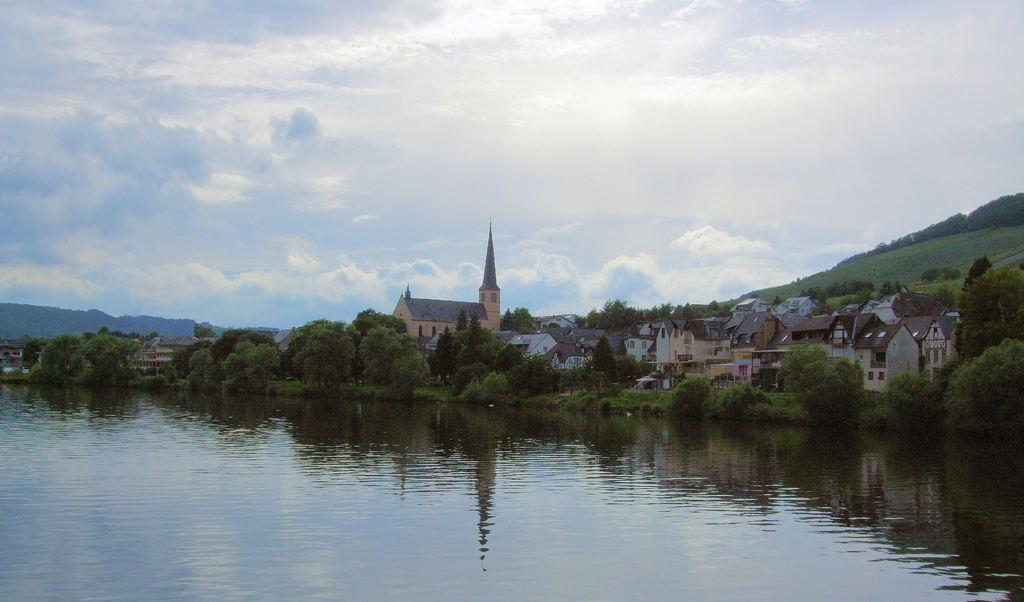What is located in the center of the image? There are trees, buildings, and plants in the center of the image. What can be seen at the bottom of the image? There is a river at the bottom of the image. What is visible in the background of the image? There are mountains in the background of the image. What is visible at the top of the image? The sky is visible at the top of the image. How many cars are parked on the cushion in the image? There are no cars or cushions present in the image. What type of bed can be seen in the image? There is no bed present in the image. 